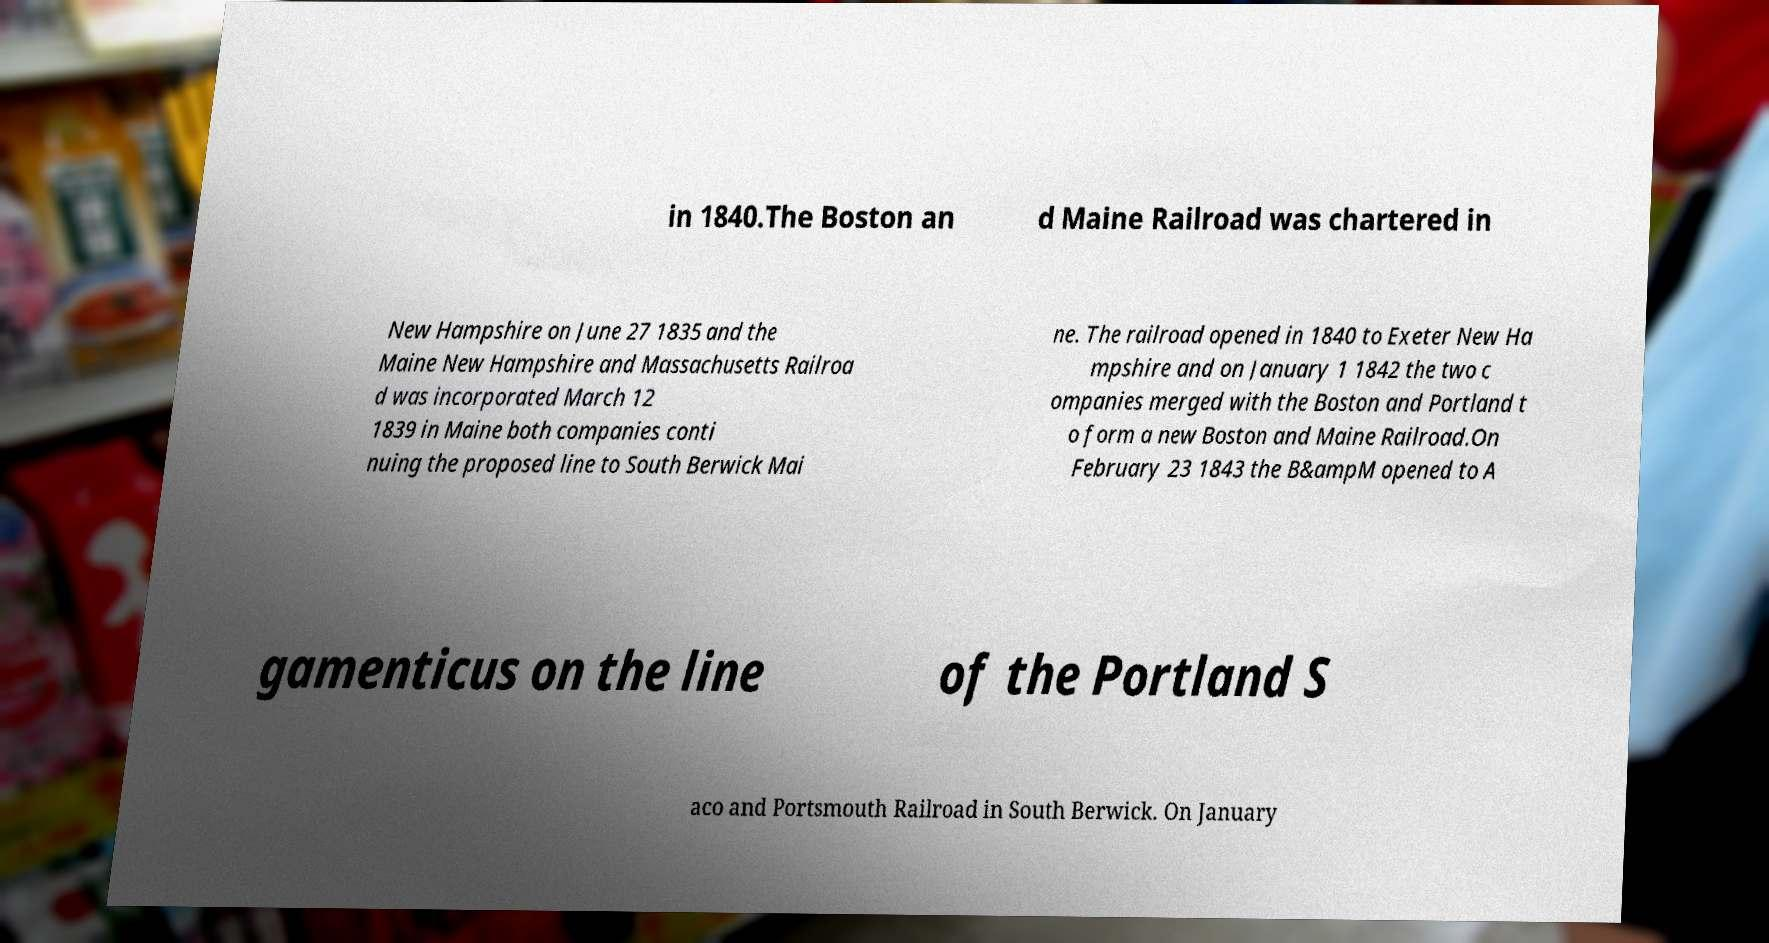Could you assist in decoding the text presented in this image and type it out clearly? in 1840.The Boston an d Maine Railroad was chartered in New Hampshire on June 27 1835 and the Maine New Hampshire and Massachusetts Railroa d was incorporated March 12 1839 in Maine both companies conti nuing the proposed line to South Berwick Mai ne. The railroad opened in 1840 to Exeter New Ha mpshire and on January 1 1842 the two c ompanies merged with the Boston and Portland t o form a new Boston and Maine Railroad.On February 23 1843 the B&ampM opened to A gamenticus on the line of the Portland S aco and Portsmouth Railroad in South Berwick. On January 